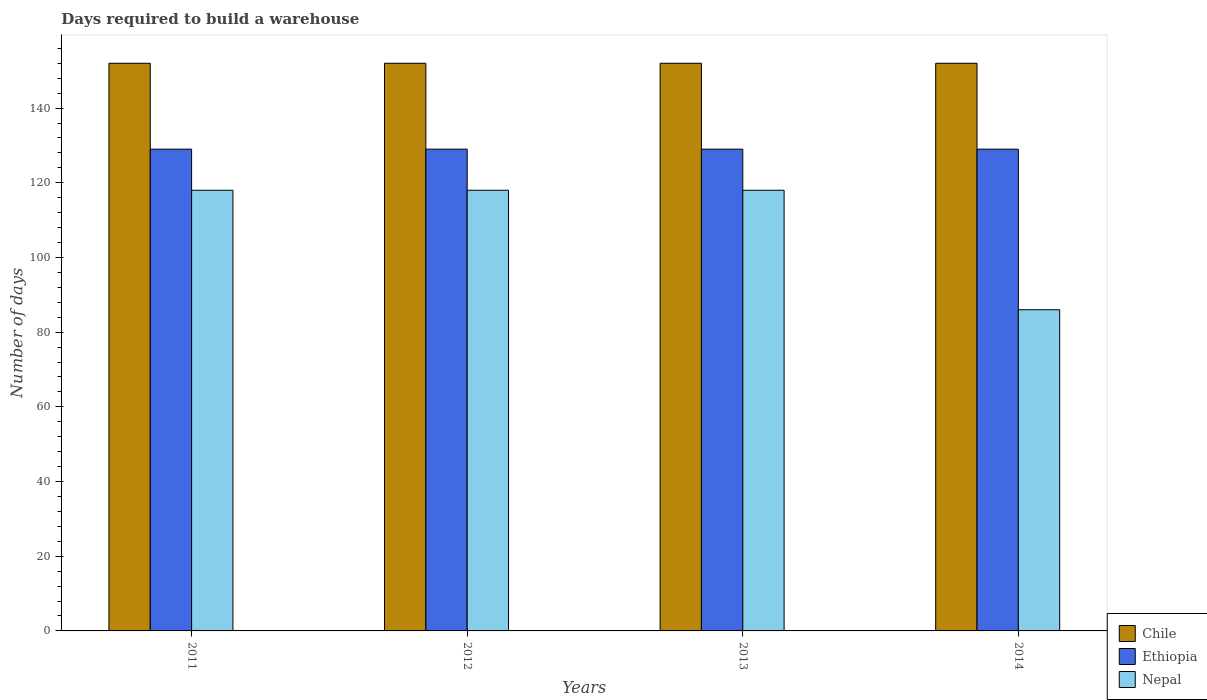How many groups of bars are there?
Your answer should be compact. 4. Are the number of bars per tick equal to the number of legend labels?
Make the answer very short. Yes. How many bars are there on the 2nd tick from the left?
Offer a very short reply. 3. How many bars are there on the 3rd tick from the right?
Make the answer very short. 3. In how many cases, is the number of bars for a given year not equal to the number of legend labels?
Offer a terse response. 0. What is the days required to build a warehouse in in Chile in 2013?
Your answer should be compact. 152. Across all years, what is the maximum days required to build a warehouse in in Ethiopia?
Your answer should be compact. 129. Across all years, what is the minimum days required to build a warehouse in in Chile?
Your answer should be compact. 152. In which year was the days required to build a warehouse in in Chile maximum?
Your answer should be very brief. 2011. What is the total days required to build a warehouse in in Ethiopia in the graph?
Ensure brevity in your answer.  516. What is the difference between the days required to build a warehouse in in Chile in 2011 and that in 2014?
Provide a succinct answer. 0. What is the difference between the days required to build a warehouse in in Chile in 2012 and the days required to build a warehouse in in Nepal in 2013?
Your answer should be compact. 34. What is the average days required to build a warehouse in in Chile per year?
Offer a terse response. 152. In the year 2013, what is the difference between the days required to build a warehouse in in Nepal and days required to build a warehouse in in Ethiopia?
Offer a very short reply. -11. What is the ratio of the days required to build a warehouse in in Chile in 2013 to that in 2014?
Provide a succinct answer. 1. Is the days required to build a warehouse in in Ethiopia in 2012 less than that in 2013?
Offer a very short reply. No. What does the 3rd bar from the left in 2011 represents?
Keep it short and to the point. Nepal. What does the 1st bar from the right in 2014 represents?
Your response must be concise. Nepal. Is it the case that in every year, the sum of the days required to build a warehouse in in Nepal and days required to build a warehouse in in Ethiopia is greater than the days required to build a warehouse in in Chile?
Provide a succinct answer. Yes. How many years are there in the graph?
Your answer should be compact. 4. Does the graph contain any zero values?
Your answer should be very brief. No. How are the legend labels stacked?
Provide a short and direct response. Vertical. What is the title of the graph?
Offer a terse response. Days required to build a warehouse. What is the label or title of the Y-axis?
Your answer should be very brief. Number of days. What is the Number of days in Chile in 2011?
Offer a very short reply. 152. What is the Number of days in Ethiopia in 2011?
Offer a very short reply. 129. What is the Number of days in Nepal in 2011?
Offer a terse response. 118. What is the Number of days of Chile in 2012?
Provide a short and direct response. 152. What is the Number of days in Ethiopia in 2012?
Your response must be concise. 129. What is the Number of days of Nepal in 2012?
Your response must be concise. 118. What is the Number of days in Chile in 2013?
Ensure brevity in your answer.  152. What is the Number of days of Ethiopia in 2013?
Keep it short and to the point. 129. What is the Number of days of Nepal in 2013?
Your answer should be very brief. 118. What is the Number of days of Chile in 2014?
Provide a short and direct response. 152. What is the Number of days of Ethiopia in 2014?
Your answer should be compact. 129. What is the Number of days in Nepal in 2014?
Give a very brief answer. 86. Across all years, what is the maximum Number of days in Chile?
Your response must be concise. 152. Across all years, what is the maximum Number of days of Ethiopia?
Your answer should be compact. 129. Across all years, what is the maximum Number of days of Nepal?
Offer a terse response. 118. Across all years, what is the minimum Number of days of Chile?
Your response must be concise. 152. Across all years, what is the minimum Number of days in Ethiopia?
Your response must be concise. 129. Across all years, what is the minimum Number of days of Nepal?
Make the answer very short. 86. What is the total Number of days of Chile in the graph?
Offer a very short reply. 608. What is the total Number of days of Ethiopia in the graph?
Your answer should be very brief. 516. What is the total Number of days in Nepal in the graph?
Ensure brevity in your answer.  440. What is the difference between the Number of days in Nepal in 2011 and that in 2012?
Offer a very short reply. 0. What is the difference between the Number of days of Chile in 2011 and that in 2013?
Give a very brief answer. 0. What is the difference between the Number of days in Nepal in 2011 and that in 2013?
Keep it short and to the point. 0. What is the difference between the Number of days in Ethiopia in 2011 and that in 2014?
Ensure brevity in your answer.  0. What is the difference between the Number of days in Chile in 2012 and that in 2013?
Provide a short and direct response. 0. What is the difference between the Number of days in Nepal in 2012 and that in 2013?
Your response must be concise. 0. What is the difference between the Number of days of Chile in 2011 and the Number of days of Nepal in 2013?
Offer a very short reply. 34. What is the difference between the Number of days of Ethiopia in 2011 and the Number of days of Nepal in 2013?
Your answer should be very brief. 11. What is the difference between the Number of days of Chile in 2011 and the Number of days of Nepal in 2014?
Give a very brief answer. 66. What is the difference between the Number of days of Ethiopia in 2011 and the Number of days of Nepal in 2014?
Your response must be concise. 43. What is the difference between the Number of days of Chile in 2012 and the Number of days of Nepal in 2013?
Your answer should be very brief. 34. What is the difference between the Number of days of Chile in 2012 and the Number of days of Ethiopia in 2014?
Provide a short and direct response. 23. What is the difference between the Number of days of Ethiopia in 2012 and the Number of days of Nepal in 2014?
Give a very brief answer. 43. What is the difference between the Number of days of Chile in 2013 and the Number of days of Nepal in 2014?
Offer a terse response. 66. What is the average Number of days of Chile per year?
Offer a terse response. 152. What is the average Number of days in Ethiopia per year?
Your answer should be very brief. 129. What is the average Number of days of Nepal per year?
Make the answer very short. 110. In the year 2011, what is the difference between the Number of days of Chile and Number of days of Ethiopia?
Offer a terse response. 23. In the year 2011, what is the difference between the Number of days in Chile and Number of days in Nepal?
Your answer should be very brief. 34. In the year 2012, what is the difference between the Number of days in Chile and Number of days in Nepal?
Keep it short and to the point. 34. In the year 2012, what is the difference between the Number of days of Ethiopia and Number of days of Nepal?
Give a very brief answer. 11. In the year 2013, what is the difference between the Number of days in Chile and Number of days in Nepal?
Make the answer very short. 34. In the year 2014, what is the difference between the Number of days of Chile and Number of days of Ethiopia?
Give a very brief answer. 23. What is the ratio of the Number of days in Chile in 2011 to that in 2012?
Your response must be concise. 1. What is the ratio of the Number of days in Ethiopia in 2011 to that in 2012?
Provide a succinct answer. 1. What is the ratio of the Number of days in Nepal in 2011 to that in 2012?
Ensure brevity in your answer.  1. What is the ratio of the Number of days in Chile in 2011 to that in 2014?
Your answer should be compact. 1. What is the ratio of the Number of days of Ethiopia in 2011 to that in 2014?
Make the answer very short. 1. What is the ratio of the Number of days of Nepal in 2011 to that in 2014?
Provide a succinct answer. 1.37. What is the ratio of the Number of days of Ethiopia in 2012 to that in 2013?
Your answer should be compact. 1. What is the ratio of the Number of days of Chile in 2012 to that in 2014?
Your answer should be very brief. 1. What is the ratio of the Number of days of Nepal in 2012 to that in 2014?
Your answer should be very brief. 1.37. What is the ratio of the Number of days in Nepal in 2013 to that in 2014?
Your response must be concise. 1.37. What is the difference between the highest and the second highest Number of days in Ethiopia?
Your answer should be compact. 0. What is the difference between the highest and the second highest Number of days of Nepal?
Make the answer very short. 0. What is the difference between the highest and the lowest Number of days in Ethiopia?
Your answer should be compact. 0. What is the difference between the highest and the lowest Number of days in Nepal?
Make the answer very short. 32. 